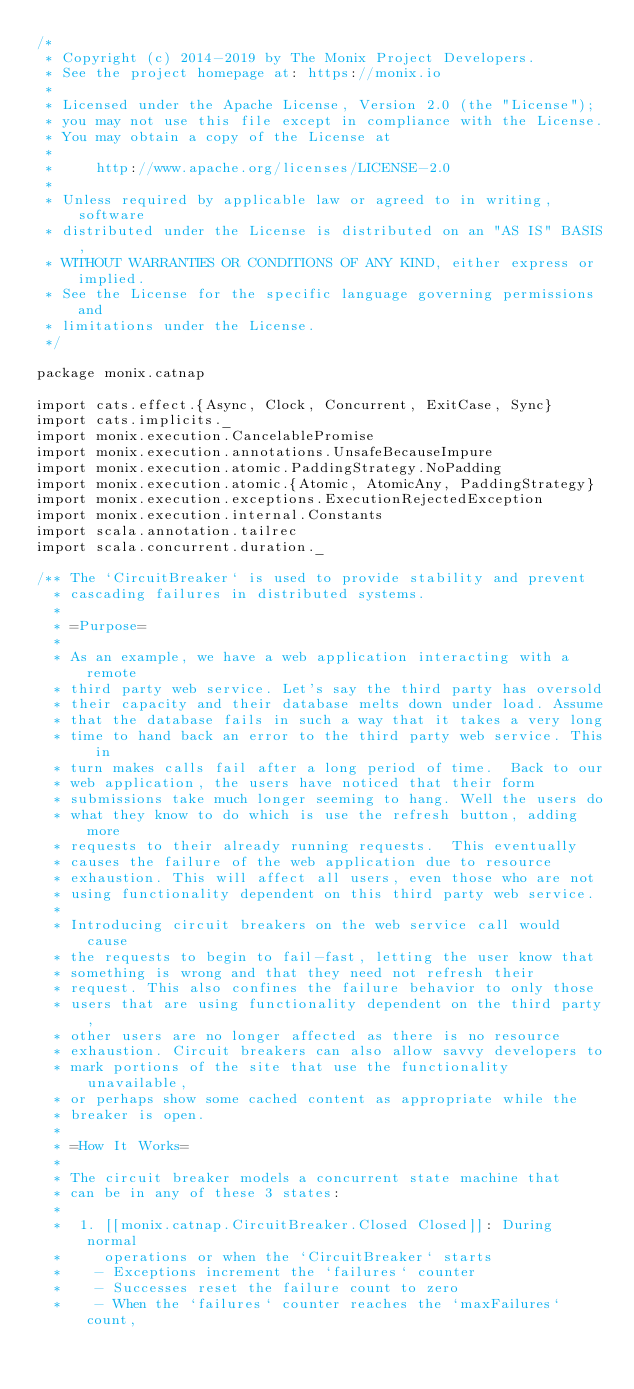<code> <loc_0><loc_0><loc_500><loc_500><_Scala_>/*
 * Copyright (c) 2014-2019 by The Monix Project Developers.
 * See the project homepage at: https://monix.io
 *
 * Licensed under the Apache License, Version 2.0 (the "License");
 * you may not use this file except in compliance with the License.
 * You may obtain a copy of the License at
 *
 *     http://www.apache.org/licenses/LICENSE-2.0
 *
 * Unless required by applicable law or agreed to in writing, software
 * distributed under the License is distributed on an "AS IS" BASIS,
 * WITHOUT WARRANTIES OR CONDITIONS OF ANY KIND, either express or implied.
 * See the License for the specific language governing permissions and
 * limitations under the License.
 */

package monix.catnap

import cats.effect.{Async, Clock, Concurrent, ExitCase, Sync}
import cats.implicits._
import monix.execution.CancelablePromise
import monix.execution.annotations.UnsafeBecauseImpure
import monix.execution.atomic.PaddingStrategy.NoPadding
import monix.execution.atomic.{Atomic, AtomicAny, PaddingStrategy}
import monix.execution.exceptions.ExecutionRejectedException
import monix.execution.internal.Constants
import scala.annotation.tailrec
import scala.concurrent.duration._

/** The `CircuitBreaker` is used to provide stability and prevent
  * cascading failures in distributed systems.
  *
  * =Purpose=
  *
  * As an example, we have a web application interacting with a remote
  * third party web service. Let's say the third party has oversold
  * their capacity and their database melts down under load. Assume
  * that the database fails in such a way that it takes a very long
  * time to hand back an error to the third party web service. This in
  * turn makes calls fail after a long period of time.  Back to our
  * web application, the users have noticed that their form
  * submissions take much longer seeming to hang. Well the users do
  * what they know to do which is use the refresh button, adding more
  * requests to their already running requests.  This eventually
  * causes the failure of the web application due to resource
  * exhaustion. This will affect all users, even those who are not
  * using functionality dependent on this third party web service.
  *
  * Introducing circuit breakers on the web service call would cause
  * the requests to begin to fail-fast, letting the user know that
  * something is wrong and that they need not refresh their
  * request. This also confines the failure behavior to only those
  * users that are using functionality dependent on the third party,
  * other users are no longer affected as there is no resource
  * exhaustion. Circuit breakers can also allow savvy developers to
  * mark portions of the site that use the functionality unavailable,
  * or perhaps show some cached content as appropriate while the
  * breaker is open.
  *
  * =How It Works=
  *
  * The circuit breaker models a concurrent state machine that
  * can be in any of these 3 states:
  *
  *  1. [[monix.catnap.CircuitBreaker.Closed Closed]]: During normal
  *     operations or when the `CircuitBreaker` starts
  *    - Exceptions increment the `failures` counter
  *    - Successes reset the failure count to zero
  *    - When the `failures` counter reaches the `maxFailures` count,</code> 